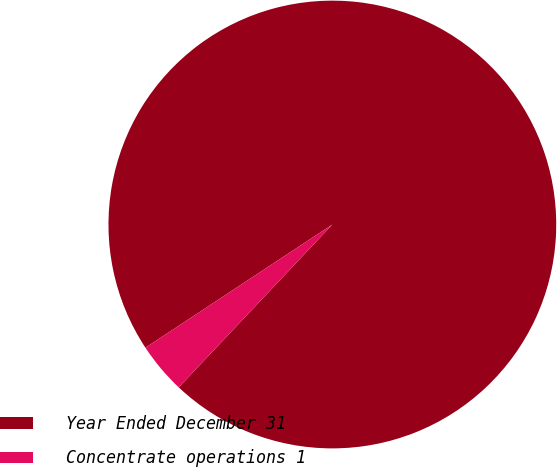Convert chart. <chart><loc_0><loc_0><loc_500><loc_500><pie_chart><fcel>Year Ended December 31<fcel>Concentrate operations 1<nl><fcel>96.31%<fcel>3.69%<nl></chart> 